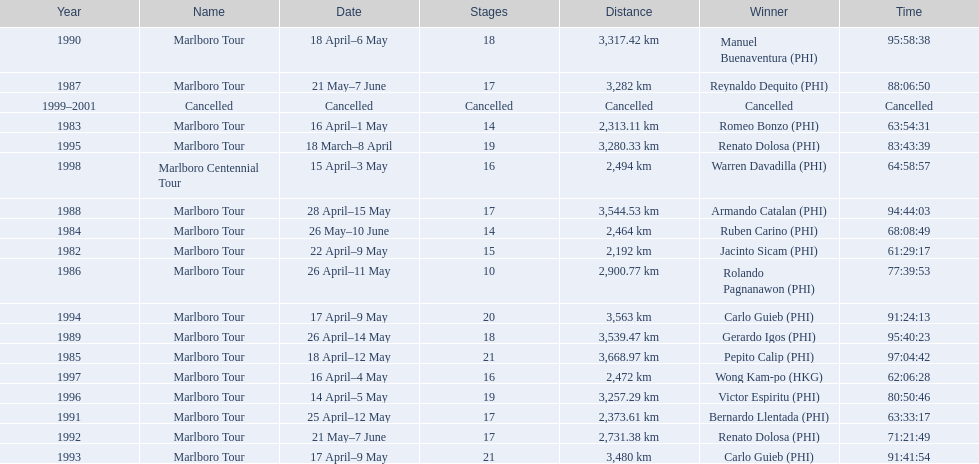What were the tour names during le tour de filipinas? Marlboro Tour, Marlboro Tour, Marlboro Tour, Marlboro Tour, Marlboro Tour, Marlboro Tour, Marlboro Tour, Marlboro Tour, Marlboro Tour, Marlboro Tour, Marlboro Tour, Marlboro Tour, Marlboro Tour, Marlboro Tour, Marlboro Tour, Marlboro Tour, Marlboro Centennial Tour, Cancelled. What were the recorded distances for each marlboro tour? 2,192 km, 2,313.11 km, 2,464 km, 3,668.97 km, 2,900.77 km, 3,282 km, 3,544.53 km, 3,539.47 km, 3,317.42 km, 2,373.61 km, 2,731.38 km, 3,480 km, 3,563 km, 3,280.33 km, 3,257.29 km, 2,472 km. And of those distances, which was the longest? 3,668.97 km. 